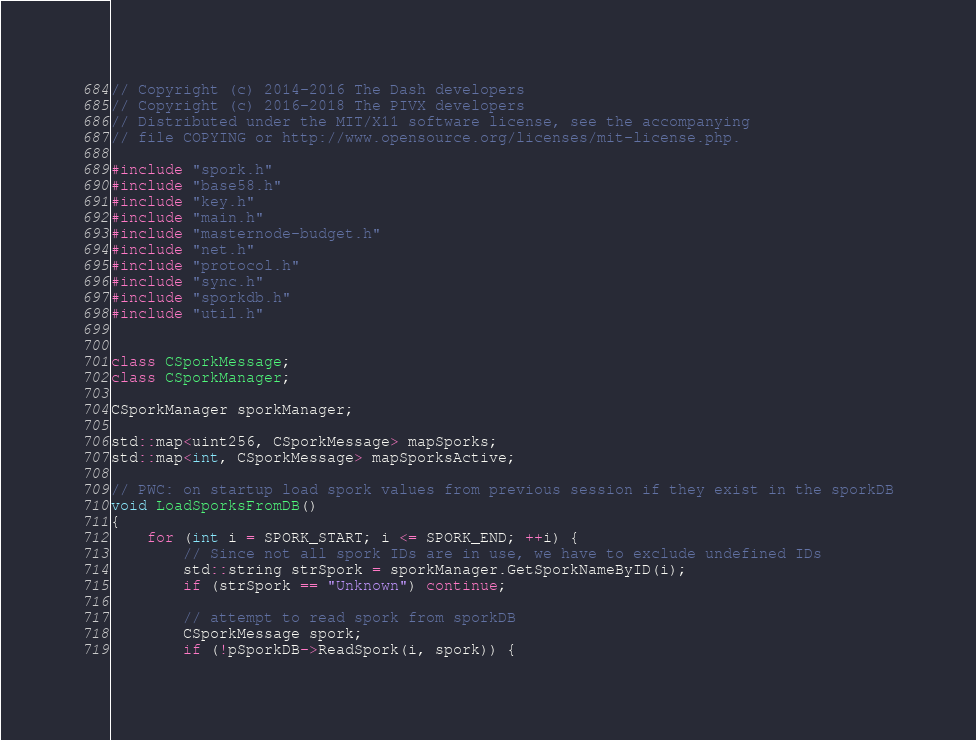<code> <loc_0><loc_0><loc_500><loc_500><_C++_>// Copyright (c) 2014-2016 The Dash developers
// Copyright (c) 2016-2018 The PIVX developers
// Distributed under the MIT/X11 software license, see the accompanying
// file COPYING or http://www.opensource.org/licenses/mit-license.php.

#include "spork.h"
#include "base58.h"
#include "key.h"
#include "main.h"
#include "masternode-budget.h"
#include "net.h"
#include "protocol.h"
#include "sync.h"
#include "sporkdb.h"
#include "util.h"


class CSporkMessage;
class CSporkManager;

CSporkManager sporkManager;

std::map<uint256, CSporkMessage> mapSporks;
std::map<int, CSporkMessage> mapSporksActive;

// PWC: on startup load spork values from previous session if they exist in the sporkDB
void LoadSporksFromDB()
{
    for (int i = SPORK_START; i <= SPORK_END; ++i) {
        // Since not all spork IDs are in use, we have to exclude undefined IDs
        std::string strSpork = sporkManager.GetSporkNameByID(i);
        if (strSpork == "Unknown") continue;

        // attempt to read spork from sporkDB
        CSporkMessage spork;
        if (!pSporkDB->ReadSpork(i, spork)) {</code> 